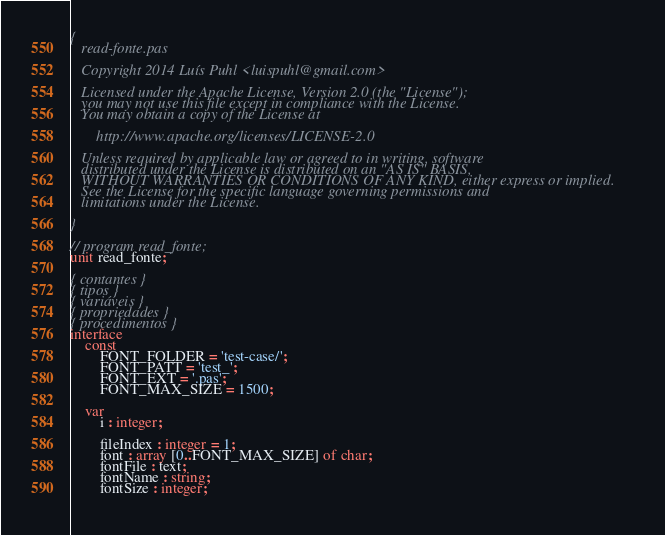<code> <loc_0><loc_0><loc_500><loc_500><_Pascal_>{
   read-fonte.pas
   
   Copyright 2014 Luís Puhl <luispuhl@gmail.com>
   
   Licensed under the Apache License, Version 2.0 (the "License");
   you may not use this file except in compliance with the License.
   You may obtain a copy of the License at

       http://www.apache.org/licenses/LICENSE-2.0

   Unless required by applicable law or agreed to in writing, software
   distributed under the License is distributed on an "AS IS" BASIS,
   WITHOUT WARRANTIES OR CONDITIONS OF ANY KIND, either express or implied.
   See the License for the specific language governing permissions and
   limitations under the License.
   
}

// program read_fonte;
unit read_fonte;

{ contantes }
{ tipos }
{ variáveis }
{ propriedades }
{ procedimentos }
interface
	const
		FONT_FOLDER = 'test-case/';
		FONT_PATT = 'test_';
		FONT_EXT = '.pas';
		FONT_MAX_SIZE = 1500;

	var
		i : integer;
		
		fileIndex : integer = 1;
		font : array [0..FONT_MAX_SIZE] of char;
		fontFile : text;
		fontName : string;
		fontSize : integer;
		</code> 